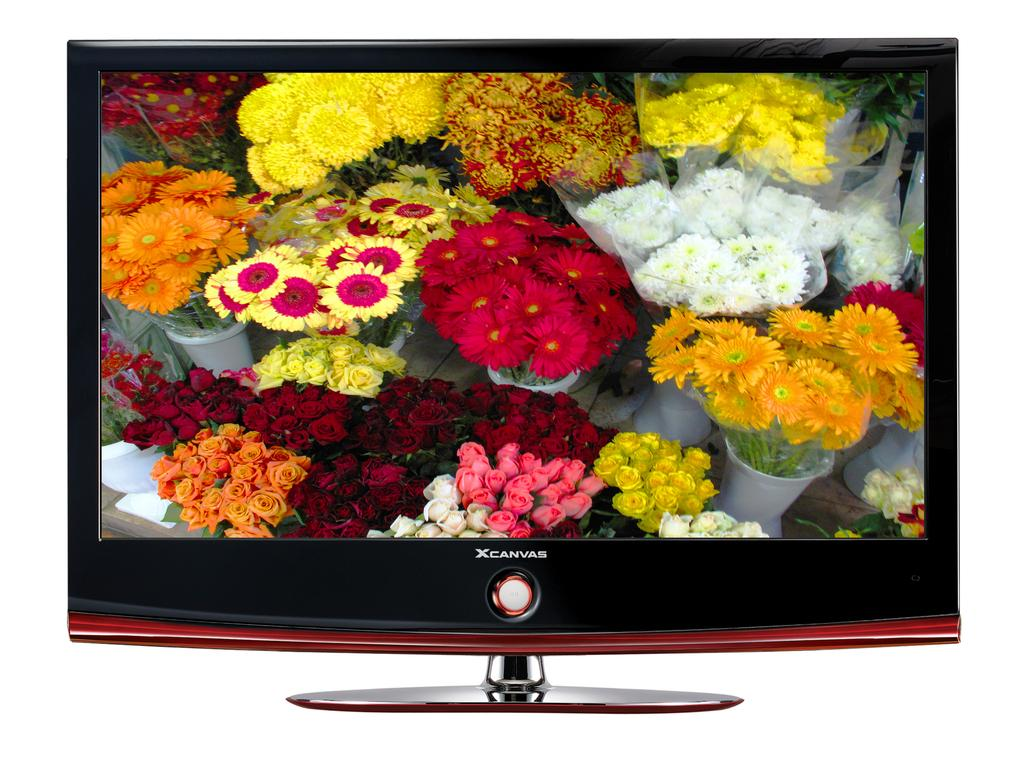<image>
Create a compact narrative representing the image presented. An XCanvas screen showing a variety of different flowers. 